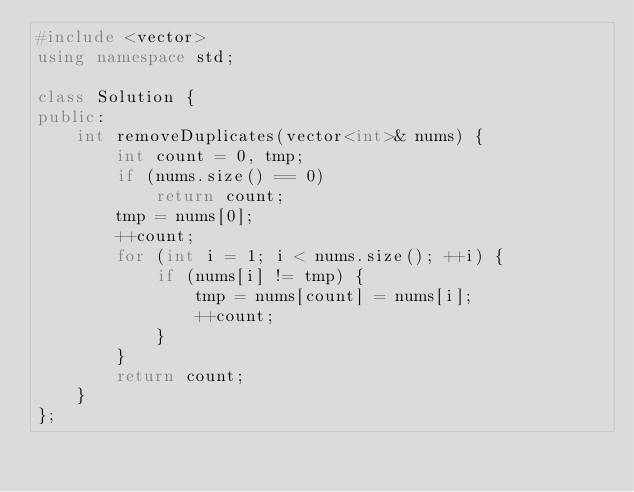Convert code to text. <code><loc_0><loc_0><loc_500><loc_500><_C++_>#include <vector>
using namespace std;

class Solution {
public:
    int removeDuplicates(vector<int>& nums) {
        int count = 0, tmp;
        if (nums.size() == 0)
            return count;
        tmp = nums[0];
        ++count;
        for (int i = 1; i < nums.size(); ++i) {
            if (nums[i] != tmp) {
                tmp = nums[count] = nums[i];
                ++count;
            }
        }
        return count;
    }
};</code> 